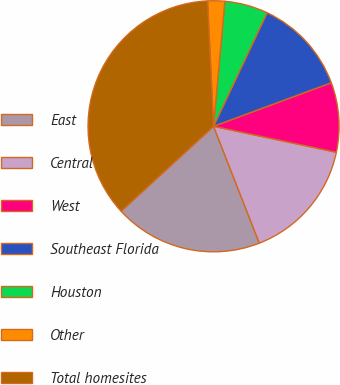Convert chart. <chart><loc_0><loc_0><loc_500><loc_500><pie_chart><fcel>East<fcel>Central<fcel>West<fcel>Southeast Florida<fcel>Houston<fcel>Other<fcel>Total homesites<nl><fcel>19.12%<fcel>15.74%<fcel>8.96%<fcel>12.35%<fcel>5.58%<fcel>2.19%<fcel>36.06%<nl></chart> 